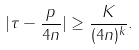Convert formula to latex. <formula><loc_0><loc_0><loc_500><loc_500>| \tau - \frac { p } { 4 n } | \geq \frac { K } { ( 4 n ) ^ { k } } .</formula> 